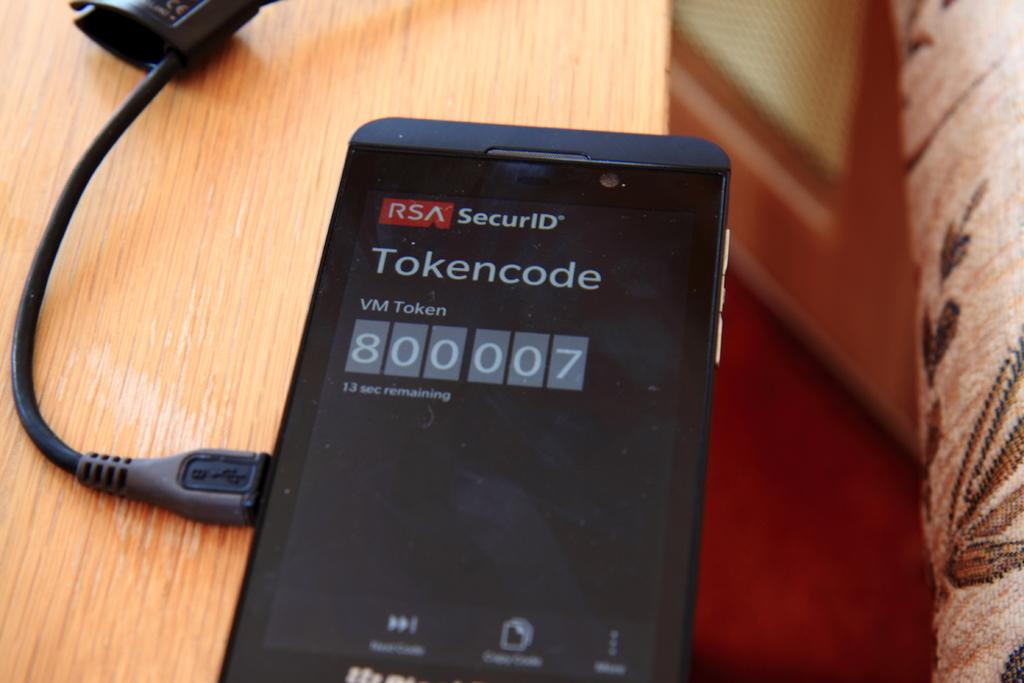<image>
Write a terse but informative summary of the picture. an electronic device with a tokencode on it 